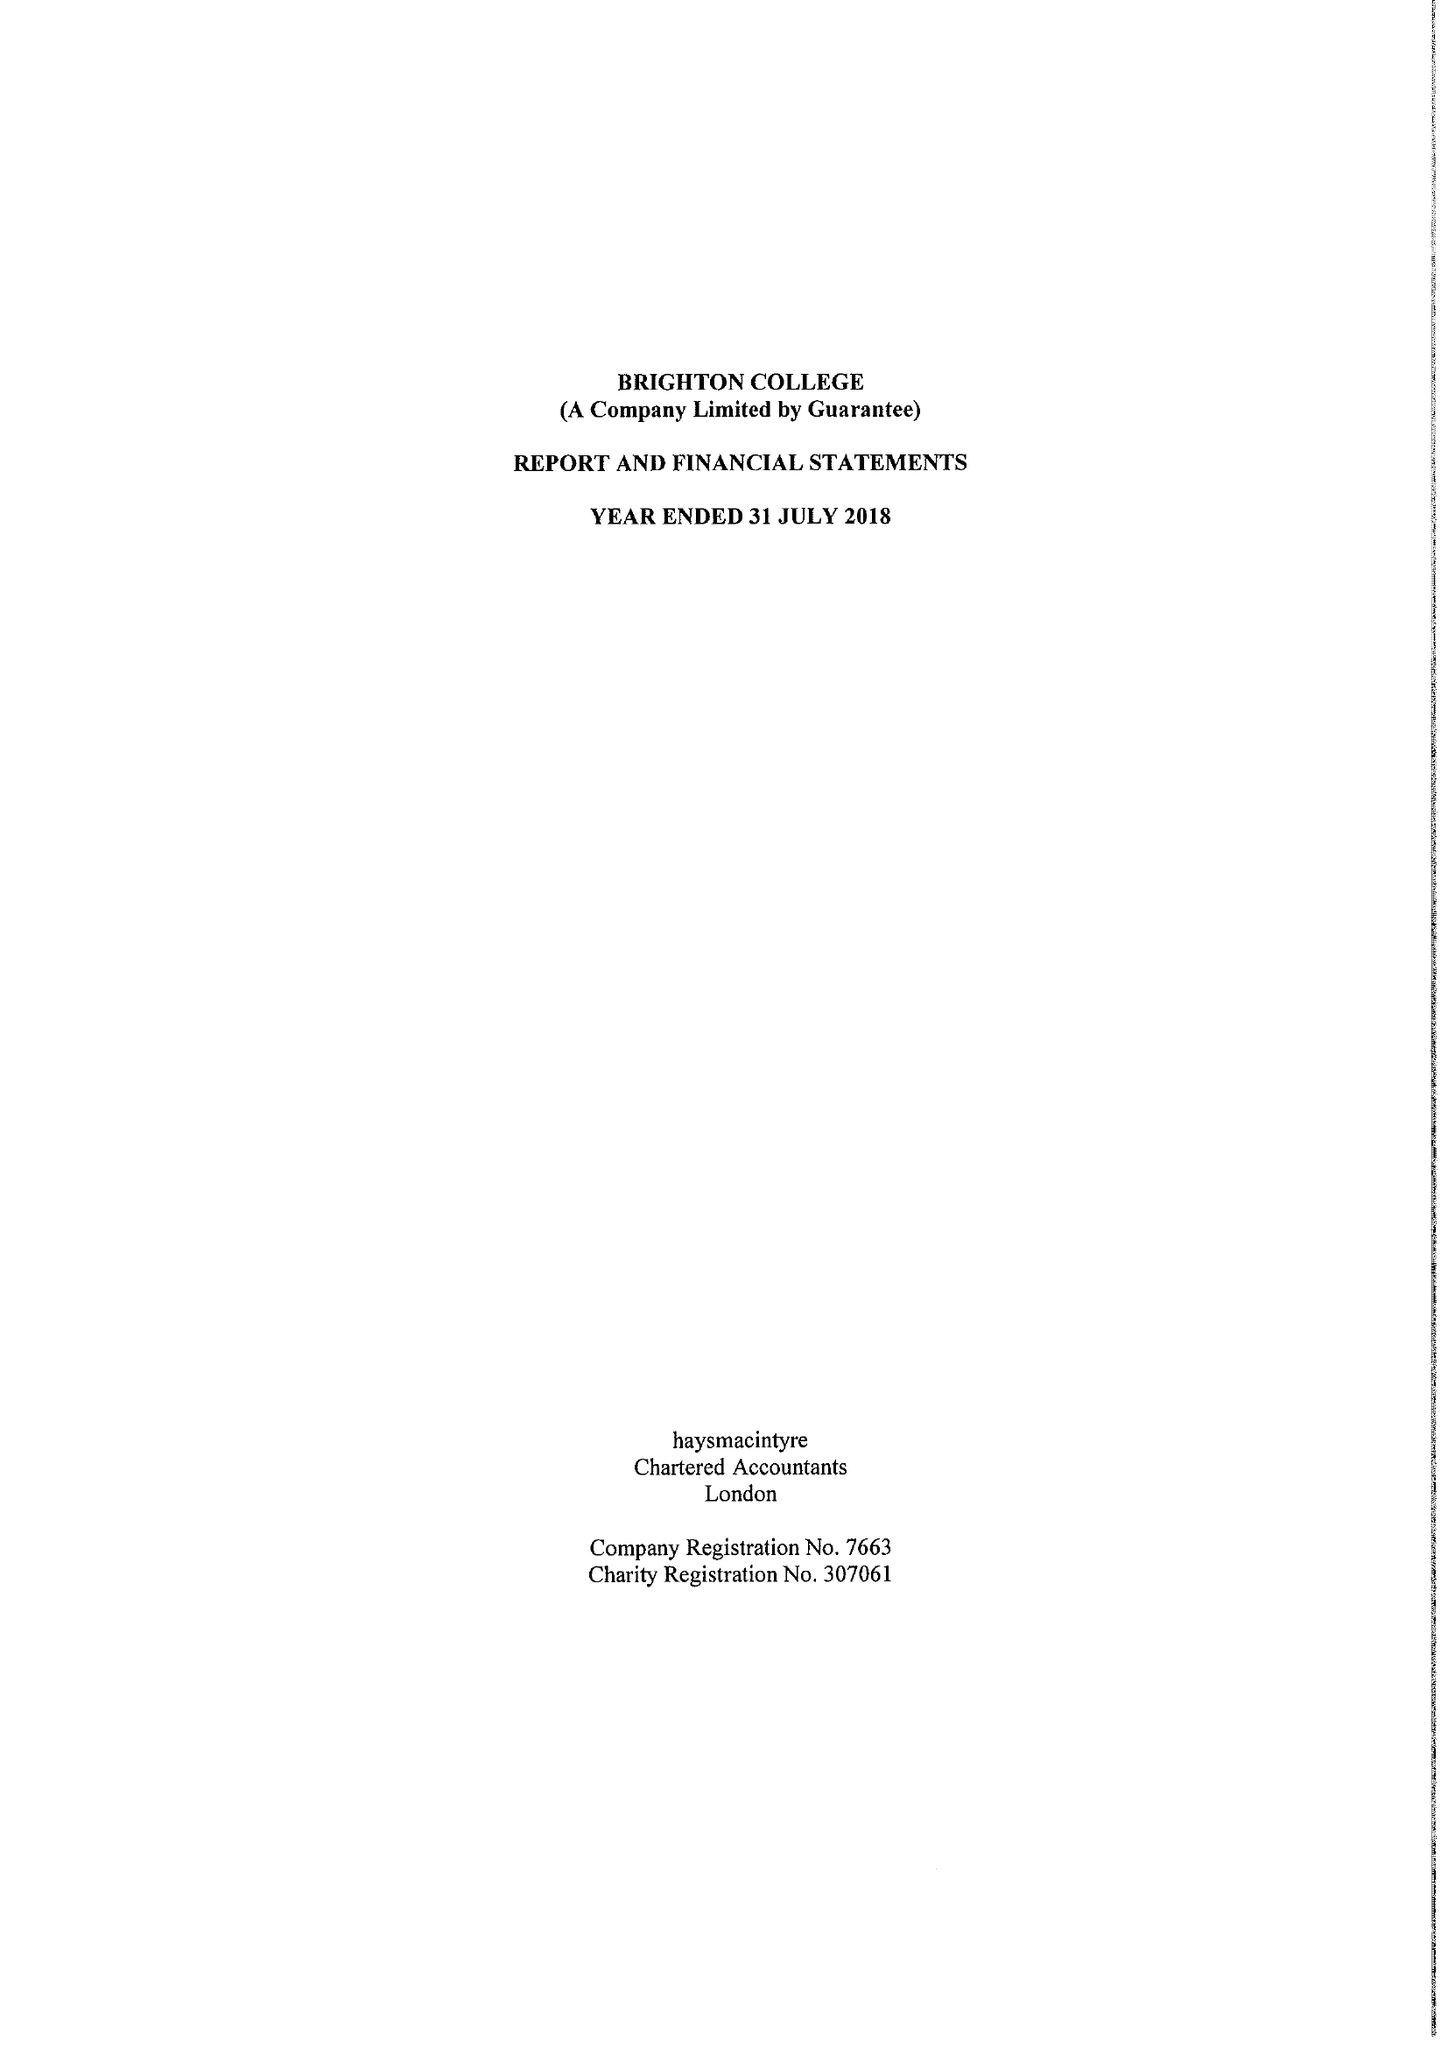What is the value for the spending_annually_in_british_pounds?
Answer the question using a single word or phrase. 41079000.00 